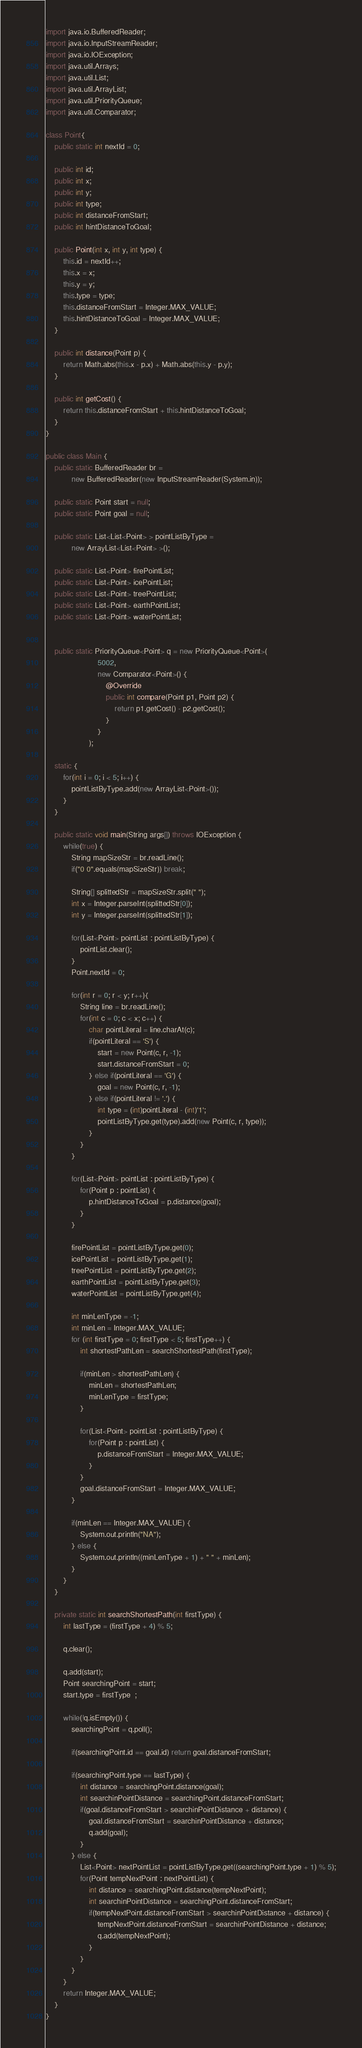<code> <loc_0><loc_0><loc_500><loc_500><_Java_>import java.io.BufferedReader;
import java.io.InputStreamReader;
import java.io.IOException;
import java.util.Arrays;
import java.util.List;
import java.util.ArrayList;
import java.util.PriorityQueue;
import java.util.Comparator;
     
class Point{
    public static int nextId = 0;
 
    public int id;
    public int x;
    public int y;
    public int type;
    public int distanceFromStart;
    public int hintDistanceToGoal;
    
    public Point(int x, int y, int type) {
        this.id = nextId++;
        this.x = x;
        this.y = y;
        this.type = type;
        this.distanceFromStart = Integer.MAX_VALUE;
        this.hintDistanceToGoal = Integer.MAX_VALUE;
    }
 
    public int distance(Point p) {
        return Math.abs(this.x - p.x) + Math.abs(this.y - p.y);
    }
    
    public int getCost() {
        return this.distanceFromStart + this.hintDistanceToGoal;
    }
}
 
public class Main {
    public static BufferedReader br =
            new BufferedReader(new InputStreamReader(System.in));
 
    public static Point start = null;
    public static Point goal = null;
 
    public static List<List<Point> > pointListByType =
            new ArrayList<List<Point> >();
 
    public static List<Point> firePointList;
    public static List<Point> icePointList;
    public static List<Point> treePointList;
    public static List<Point> earthPointList;
    public static List<Point> waterPointList;
     

    public static PriorityQueue<Point> q = new PriorityQueue<Point>(
                        5002,
                        new Comparator<Point>() {
                            @Override
                            public int compare(Point p1, Point p2) {
                                return p1.getCost() - p2.getCost();
                            }
                        }
                    );
      
    static {
        for(int i = 0; i < 5; i++) {
            pointListByType.add(new ArrayList<Point>());
        }
    }
 
    public static void main(String args[]) throws IOException {
        while(true) {
            String mapSizeStr = br.readLine();
            if("0 0".equals(mapSizeStr)) break;
 
            String[] splittedStr = mapSizeStr.split(" ");
            int x = Integer.parseInt(splittedStr[0]);
            int y = Integer.parseInt(splittedStr[1]);
                
            for(List<Point> pointList : pointListByType) {
                pointList.clear();
            }
            Point.nextId = 0;
 
            for(int r = 0; r < y; r++){
                String line = br.readLine();
                for(int c = 0; c < x; c++) {
                    char pointLiteral = line.charAt(c);
                    if(pointLiteral == 'S') {
                        start = new Point(c, r, -1);
                        start.distanceFromStart = 0;
                    } else if(pointLiteral == 'G') {
                        goal = new Point(c, r, -1);
                    } else if(pointLiteral != '.') {
                        int type = (int)pointLiteral - (int)'1';
                        pointListByType.get(type).add(new Point(c, r, type));
                    }
                }
            }
            
            for(List<Point> pointList : pointListByType) {
                for(Point p : pointList) {
                    p.hintDistanceToGoal = p.distance(goal);
                }
            }
 
            firePointList = pointListByType.get(0);
            icePointList = pointListByType.get(1);
            treePointList = pointListByType.get(2);
            earthPointList = pointListByType.get(3);
            waterPointList = pointListByType.get(4);
 
            int minLenType = -1;
            int minLen = Integer.MAX_VALUE;
            for (int firstType = 0; firstType < 5; firstType++) {
                int shortestPathLen = searchShortestPath(firstType);
 
                if(minLen > shortestPathLen) {
                    minLen = shortestPathLen;
                    minLenType = firstType;
                }
 
                for(List<Point> pointList : pointListByType) {
                    for(Point p : pointList) {
                        p.distanceFromStart = Integer.MAX_VALUE;
                    }
                }
                goal.distanceFromStart = Integer.MAX_VALUE;
            }
 
            if(minLen == Integer.MAX_VALUE) {
                System.out.println("NA");
            } else {
                System.out.println((minLenType + 1) + " " + minLen);
            }
        }
    }
 
    private static int searchShortestPath(int firstType) {
        int lastType = (firstType + 4) % 5;
           
        q.clear();
 
        q.add(start);
        Point searchingPoint = start;
        start.type = firstType  ;
          
        while(!q.isEmpty()) {
            searchingPoint = q.poll();
              
            if(searchingPoint.id == goal.id) return goal.distanceFromStart;
 
            if(searchingPoint.type == lastType) {
                int distance = searchingPoint.distance(goal);
                int searchinPointDistance = searchingPoint.distanceFromStart;
                if(goal.distanceFromStart > searchinPointDistance + distance) {
                    goal.distanceFromStart = searchinPointDistance + distance;
                    q.add(goal);
                }
            } else {
                List<Point> nextPointList = pointListByType.get((searchingPoint.type + 1) % 5);
                for(Point tempNextPoint : nextPointList) {
                    int distance = searchingPoint.distance(tempNextPoint);
                    int searchinPointDistance = searchingPoint.distanceFromStart;
                    if(tempNextPoint.distanceFromStart > searchinPointDistance + distance) {
                        tempNextPoint.distanceFromStart = searchinPointDistance + distance;
                        q.add(tempNextPoint);
                    }
                }
            }
        }
        return Integer.MAX_VALUE;
    }
}</code> 